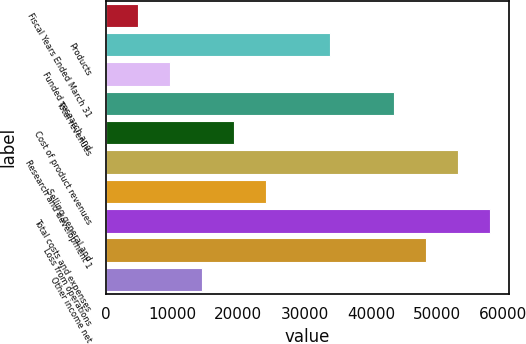Convert chart. <chart><loc_0><loc_0><loc_500><loc_500><bar_chart><fcel>Fiscal Years Ended March 31<fcel>Products<fcel>Funded research and<fcel>Total revenues<fcel>Cost of product revenues<fcel>Research and development 1<fcel>Selling general and<fcel>Total costs and expenses<fcel>Loss from operations<fcel>Other income net<nl><fcel>4836.65<fcel>33850.9<fcel>9672.36<fcel>43522.3<fcel>19343.8<fcel>53193.8<fcel>24179.5<fcel>58029.5<fcel>48358<fcel>14508.1<nl></chart> 